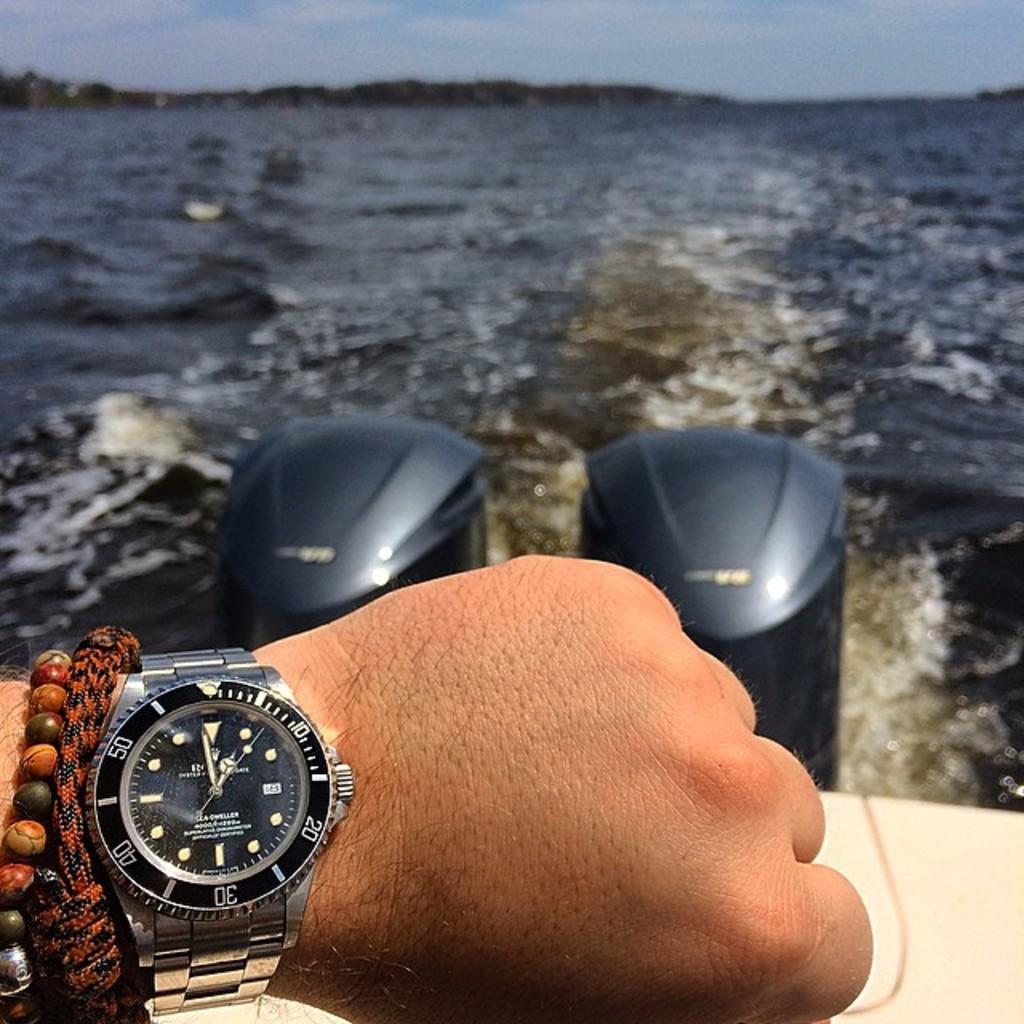<image>
Relay a brief, clear account of the picture shown. Person by the water wearing a watch which says ROLEX on it. 